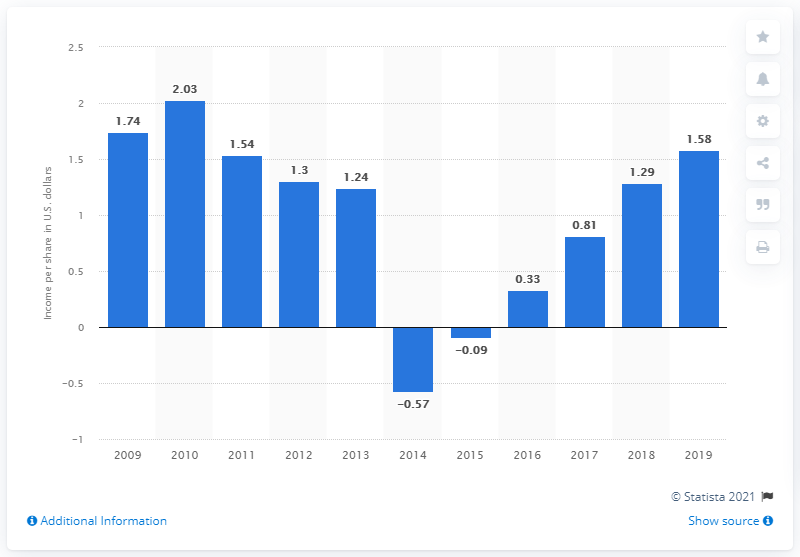Highlight a few significant elements in this photo. Petrobras' income per share a year earlier was 1.29. In 2019, the common and preferred shares of Petrobras generated an income per share of 1.58. 